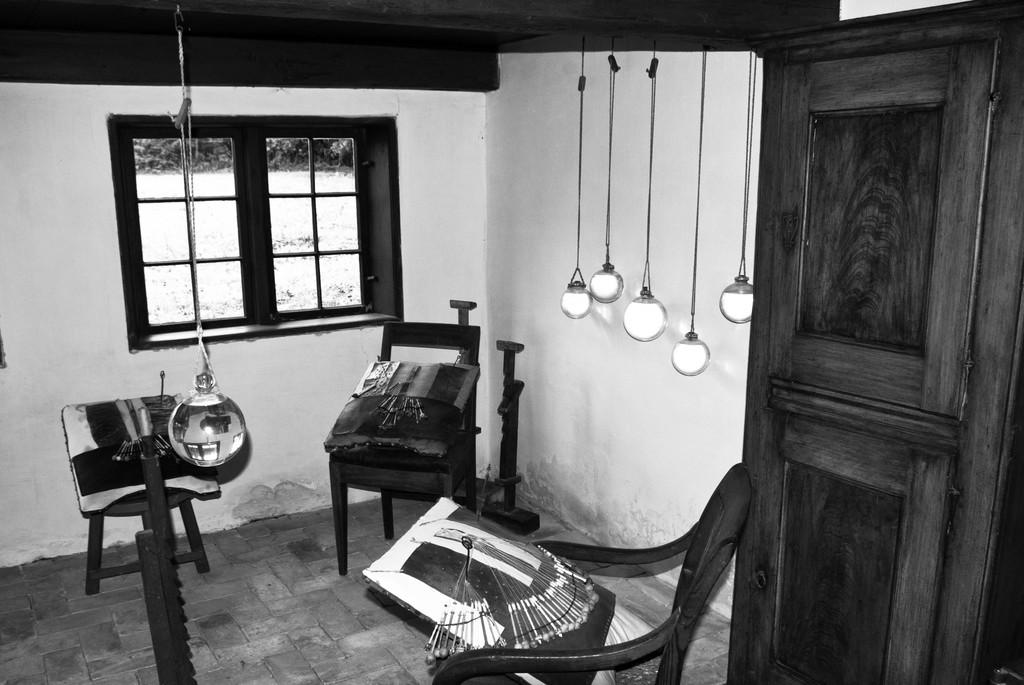What type of structure is present in the image? There is a door in the image. What can be seen illuminating the area in the image? There are lights in the image. Is there any opening for ventilation or viewing the outside in the image? Yes, there is a window in the image. What is the color scheme of the image? The image is black and white in color. How much money is being exchanged in the image? There is no indication of money or any exchange in the image. Can you tell me which character is crying in the image? There are no characters or emotions depicted in the image; it is a black and white image of a door, lights, and a window. 